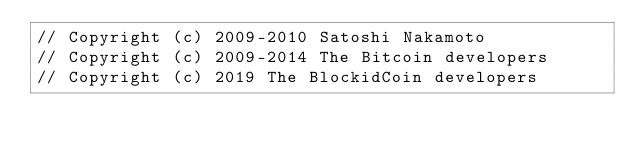Convert code to text. <code><loc_0><loc_0><loc_500><loc_500><_C++_>// Copyright (c) 2009-2010 Satoshi Nakamoto
// Copyright (c) 2009-2014 The Bitcoin developers
// Copyright (c) 2019 The BlockidCoin developers</code> 